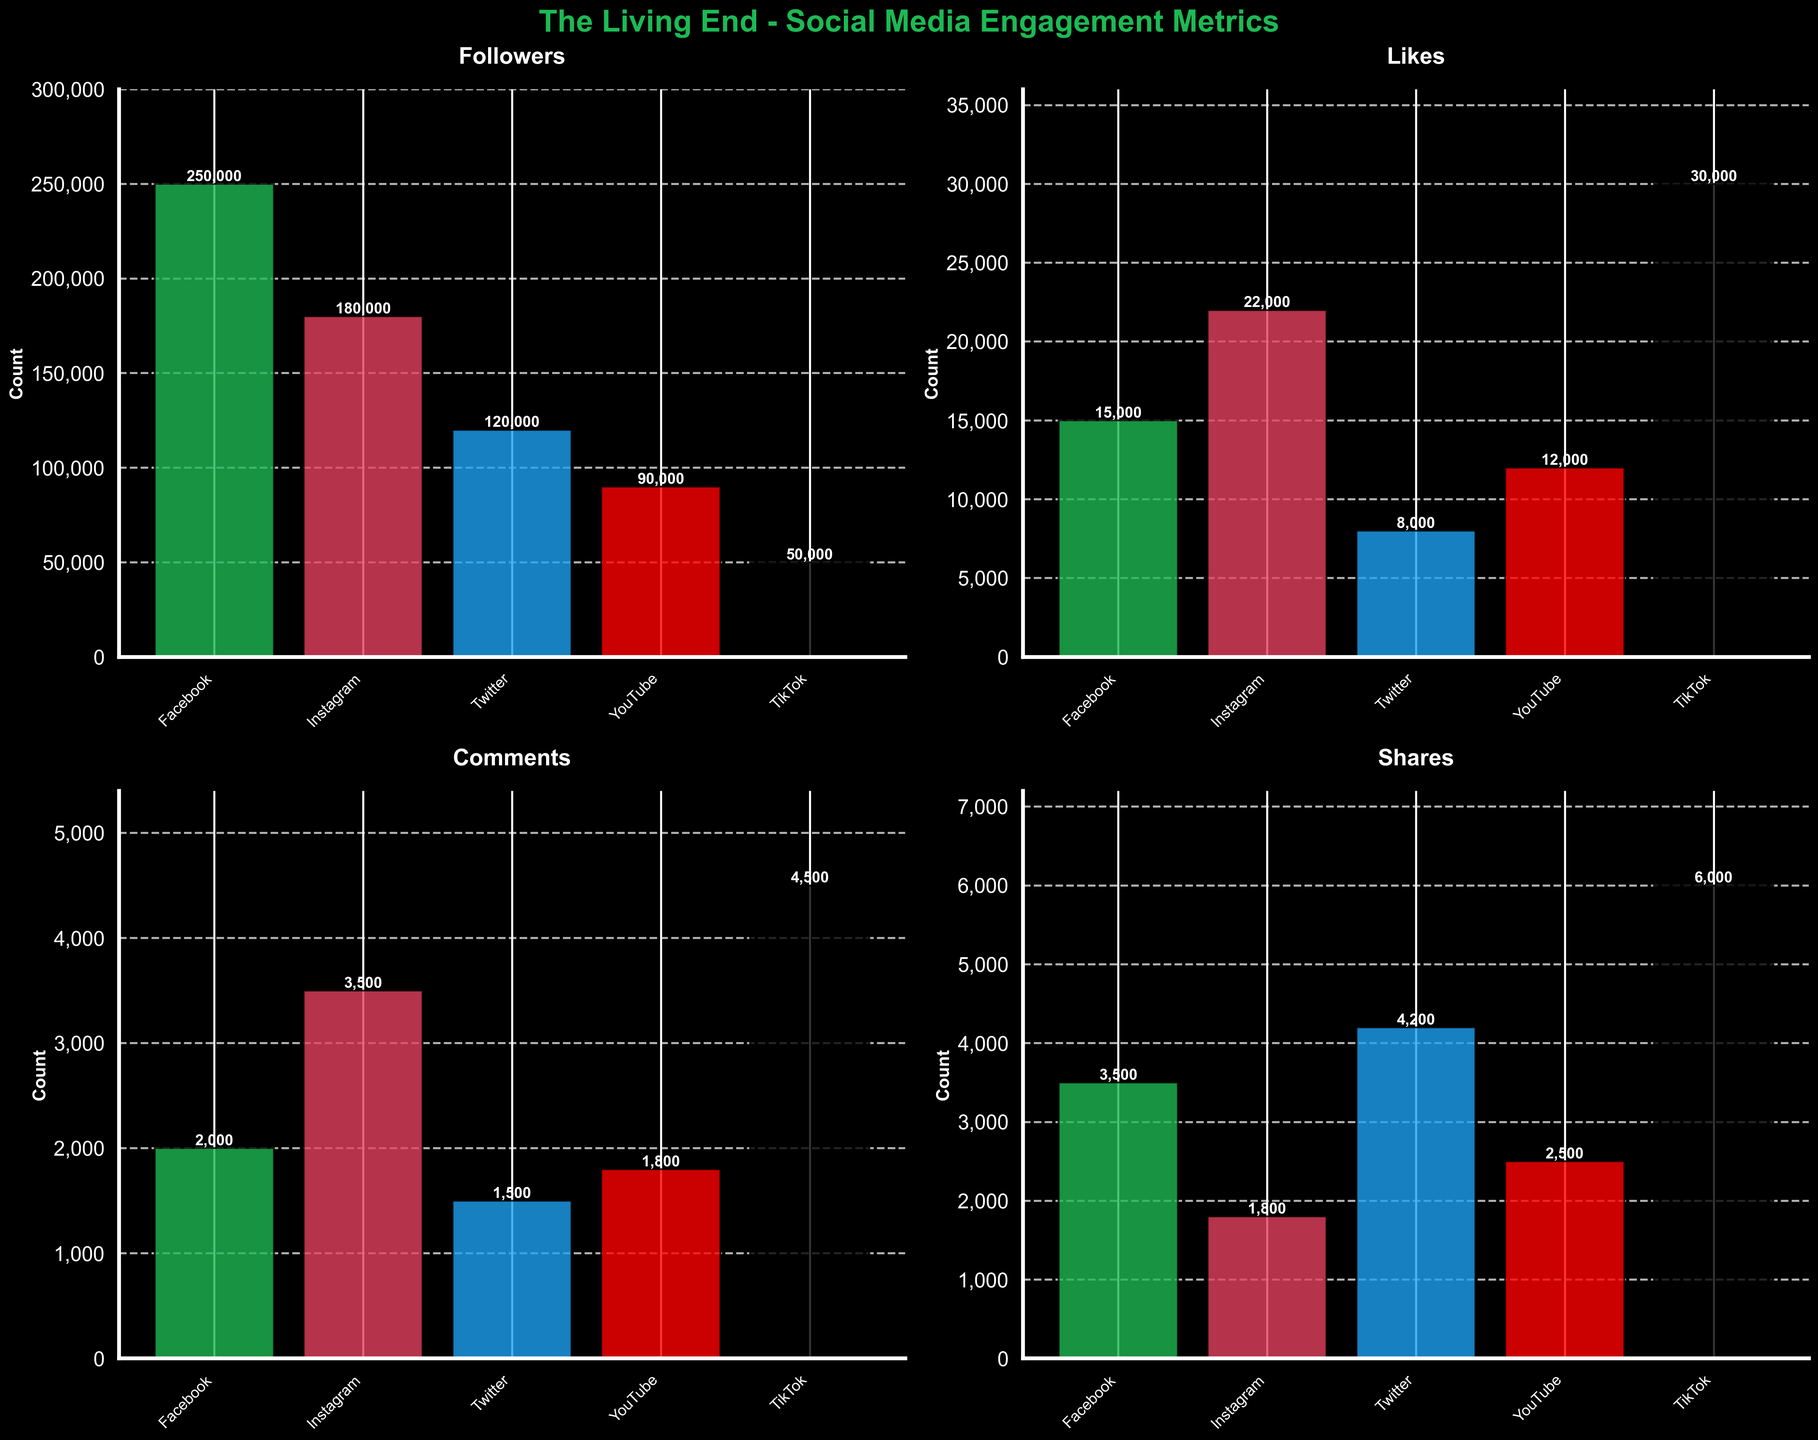What is the title of the figure? The title of the figure is presented at the top and states "The Living End - Social Media Engagement Metrics."
Answer: The Living End - Social Media Engagement Metrics Which social media platform has the highest number of likes? By looking at the bar labeled "Likes," TikTok has the tallest bar, indicating the highest number of likes.
Answer: TikTok What is the difference in the number of followers between Instagram and Twitter? Instagram has 180,000 followers and Twitter has 120,000 followers. The difference can be calculated as 180,000 - 120,000.
Answer: 60,000 Among the platforms, which one has the least number of shares? By looking at the bar labeled "Shares," Instagram has the shortest bar, indicating the least number of shares.
Answer: Instagram What is the combined total of comments from Facebook and YouTube? Facebook has 2,000 comments and YouTube has 1,800 comments. The combined total is 2,000 + 1,800.
Answer: 3,800 Which platform has more likes, YouTube or Facebook? By comparing the heights of the bars labeled "Likes" for YouTube and Facebook, Facebook has more likes with a taller bar.
Answer: Facebook How many platforms have more than 10,000 likes? By observing the bars labeled "Likes," Instagram, TikTok, and YouTube all have more than 10,000 likes. This counts up to three platforms.
Answer: 3 What is the average number of followers across all platforms? Summing the followers from each platform: 250,000 (Facebook) + 180,000 (Instagram) + 120,000 (Twitter) + 90,000 (YouTube) + 50,000 (TikTok) equals 690,000. Dividing by the 5 platforms: 690,000 / 5.
Answer: 138,000 Which platform shows a higher number of comments, Twitter or TikTok? By comparing the heights of the bars labeled "Comments" for Twitter and TikTok, TikTok has a higher count with a taller bar.
Answer: TikTok Which two metrics have the highest numbers for the same platform? By comparing the heights of bars for each platform and metric, TikTok stands out with Likes and Comments as the highest metrics.
Answer: Likes and Comments on TikTok 